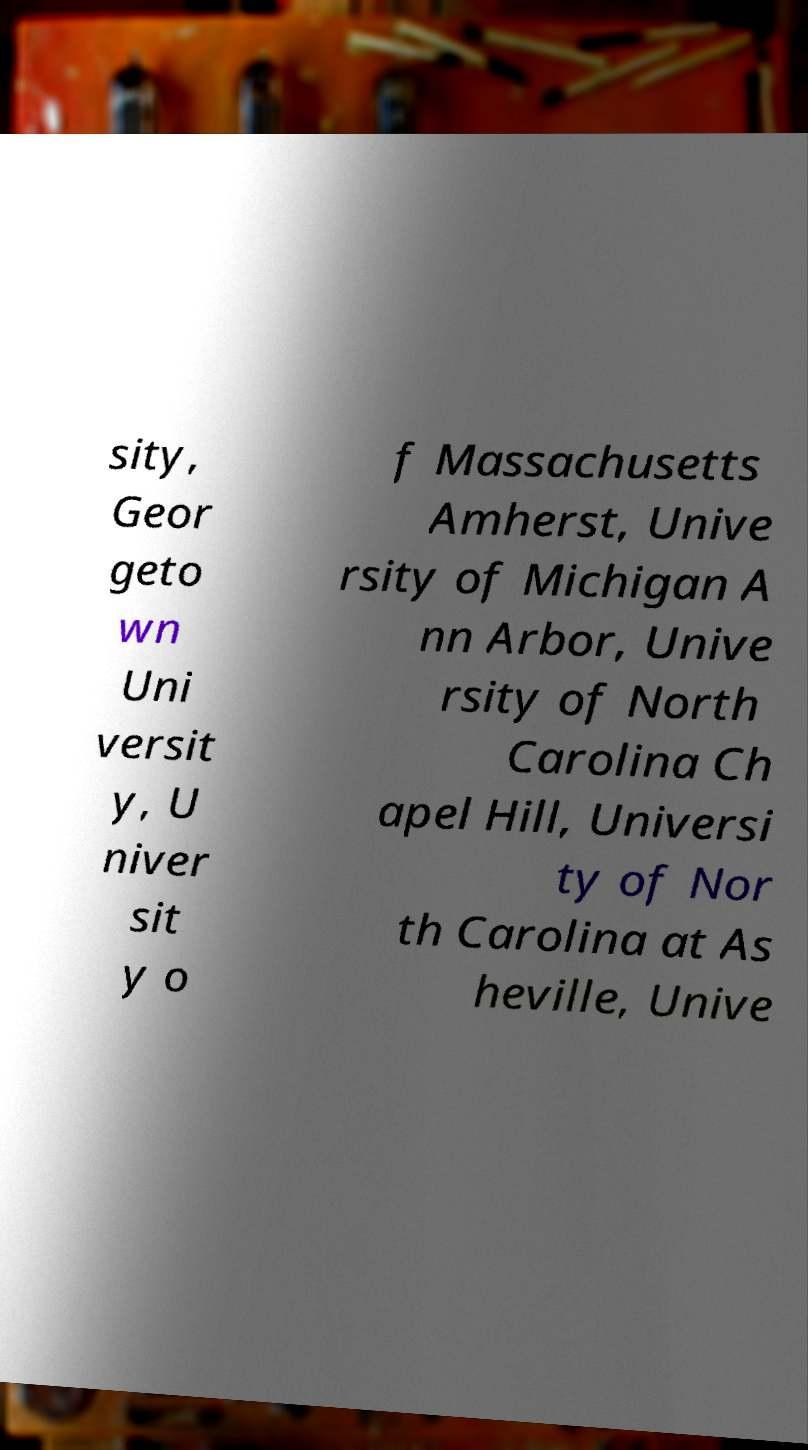Could you assist in decoding the text presented in this image and type it out clearly? sity, Geor geto wn Uni versit y, U niver sit y o f Massachusetts Amherst, Unive rsity of Michigan A nn Arbor, Unive rsity of North Carolina Ch apel Hill, Universi ty of Nor th Carolina at As heville, Unive 